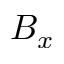Convert formula to latex. <formula><loc_0><loc_0><loc_500><loc_500>B _ { x }</formula> 